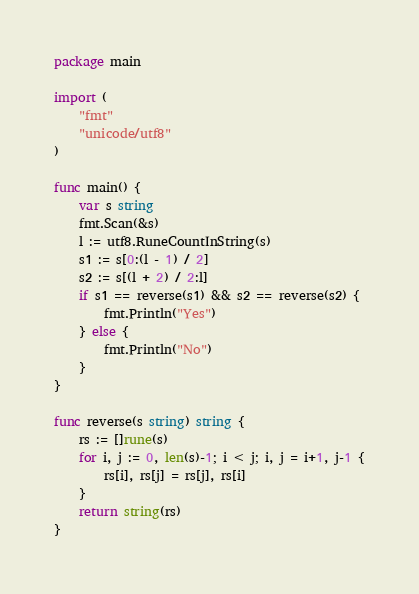<code> <loc_0><loc_0><loc_500><loc_500><_Go_>package main
 
import (
	"fmt"
	"unicode/utf8"
)
 
func main() {
	var s string
	fmt.Scan(&s)
	l := utf8.RuneCountInString(s)
	s1 := s[0:(l - 1) / 2]
	s2 := s[(l + 2) / 2:l]
	if s1 == reverse(s1) && s2 == reverse(s2) {
		fmt.Println("Yes")
	} else {
		fmt.Println("No")
	}
}

func reverse(s string) string {
    rs := []rune(s)
    for i, j := 0, len(s)-1; i < j; i, j = i+1, j-1 {
        rs[i], rs[j] = rs[j], rs[i]
    }
    return string(rs)
}</code> 